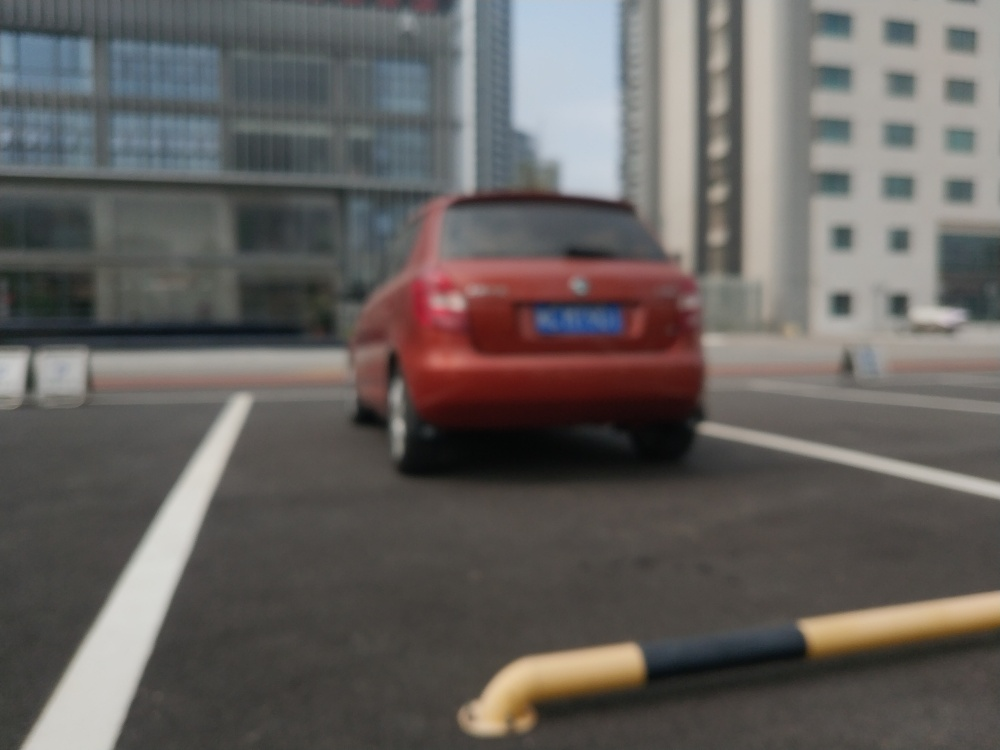Can you suggest what kind of environment the car is in, based on the background elements? Certainly! The car is situated in an urban setting, likely a well-organized parking space given the clearly marked bays. The backdrop features modern buildings, hinting at either a business district or a contemporary residential area. 